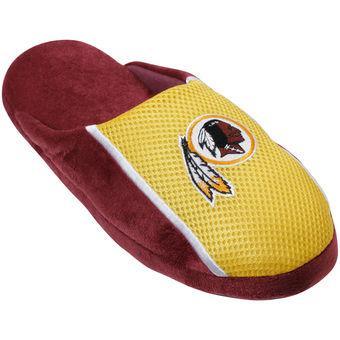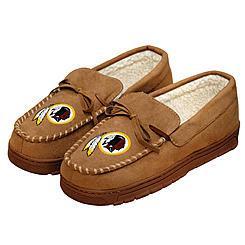The first image is the image on the left, the second image is the image on the right. Evaluate the accuracy of this statement regarding the images: "A tan pair of moccasins in one image has a sports logo on each one that is the same logo seen on a red and yellow slipper in the other image.". Is it true? Answer yes or no. Yes. 